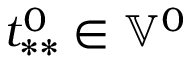Convert formula to latex. <formula><loc_0><loc_0><loc_500><loc_500>t _ { * * } ^ { 0 } \in \mathbb { V } ^ { 0 }</formula> 